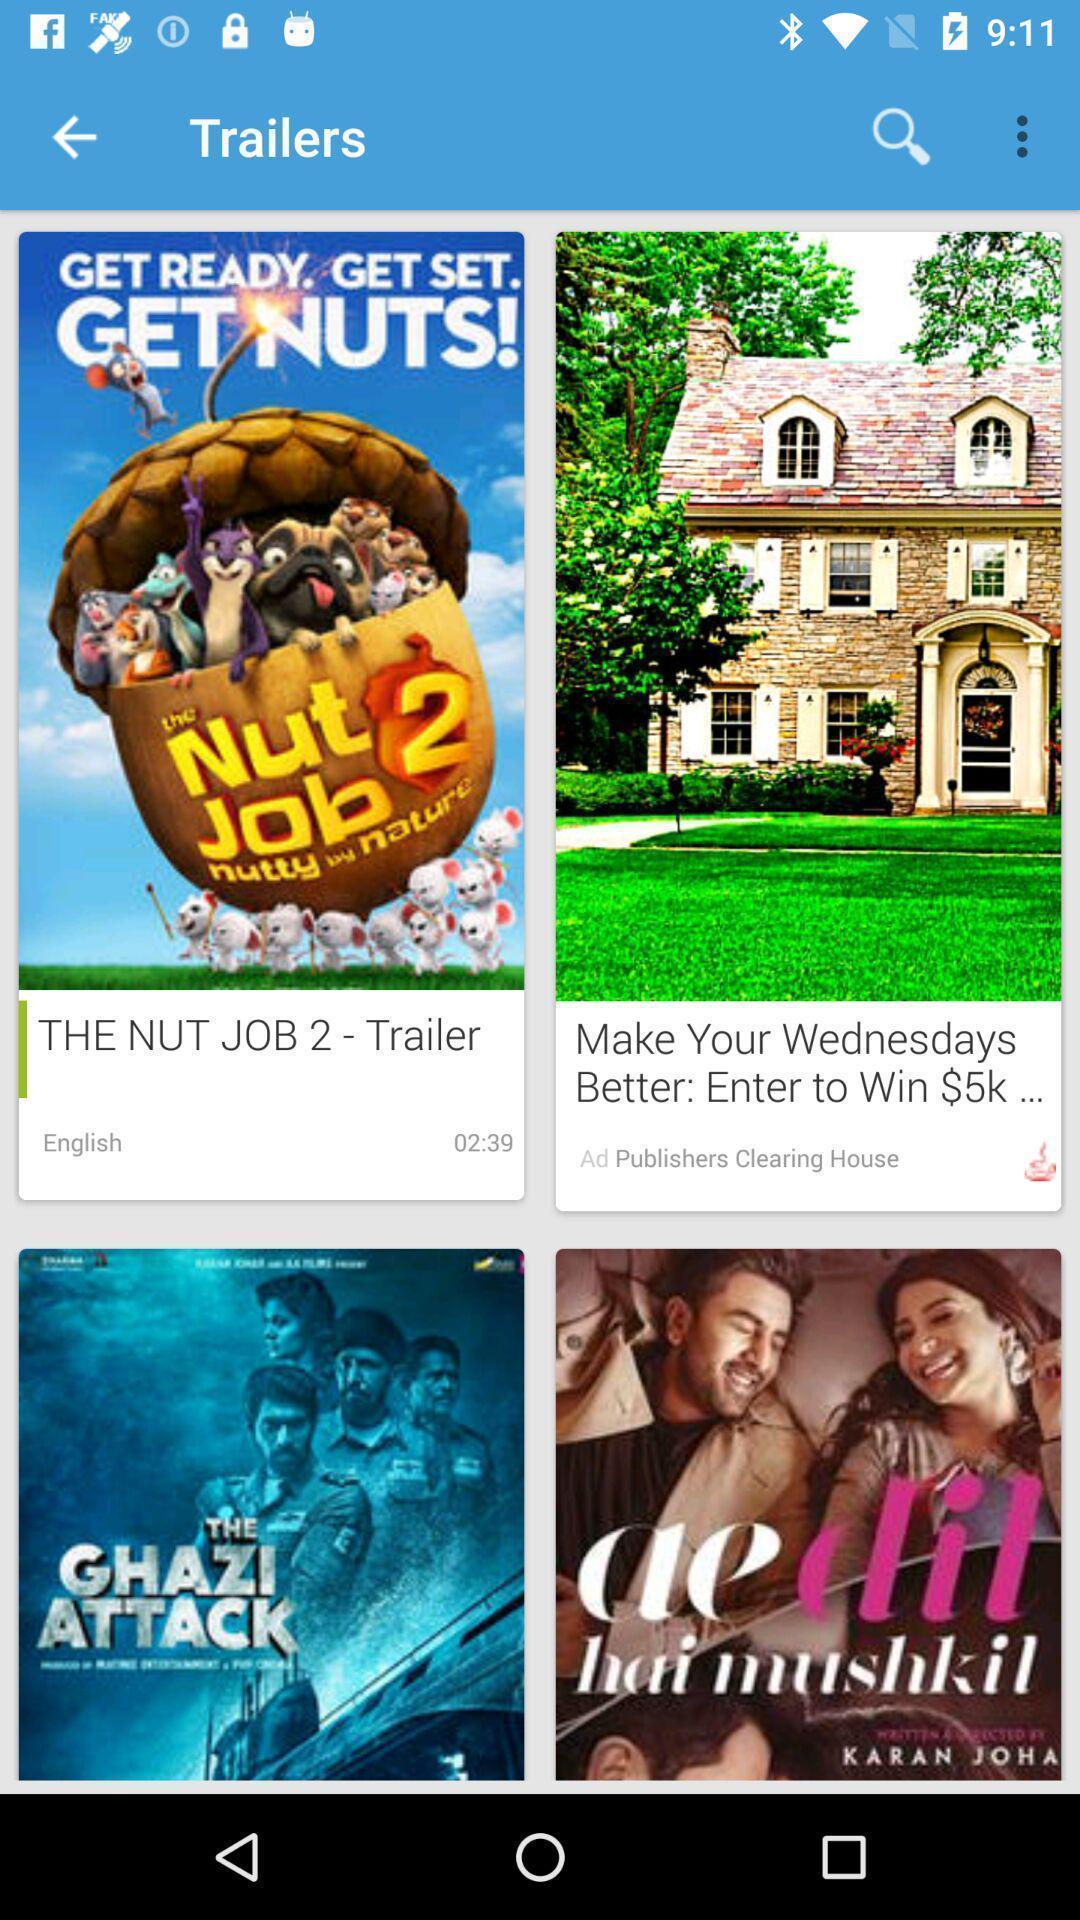Describe the key features of this screenshot. Screen showing trailers of movies. 